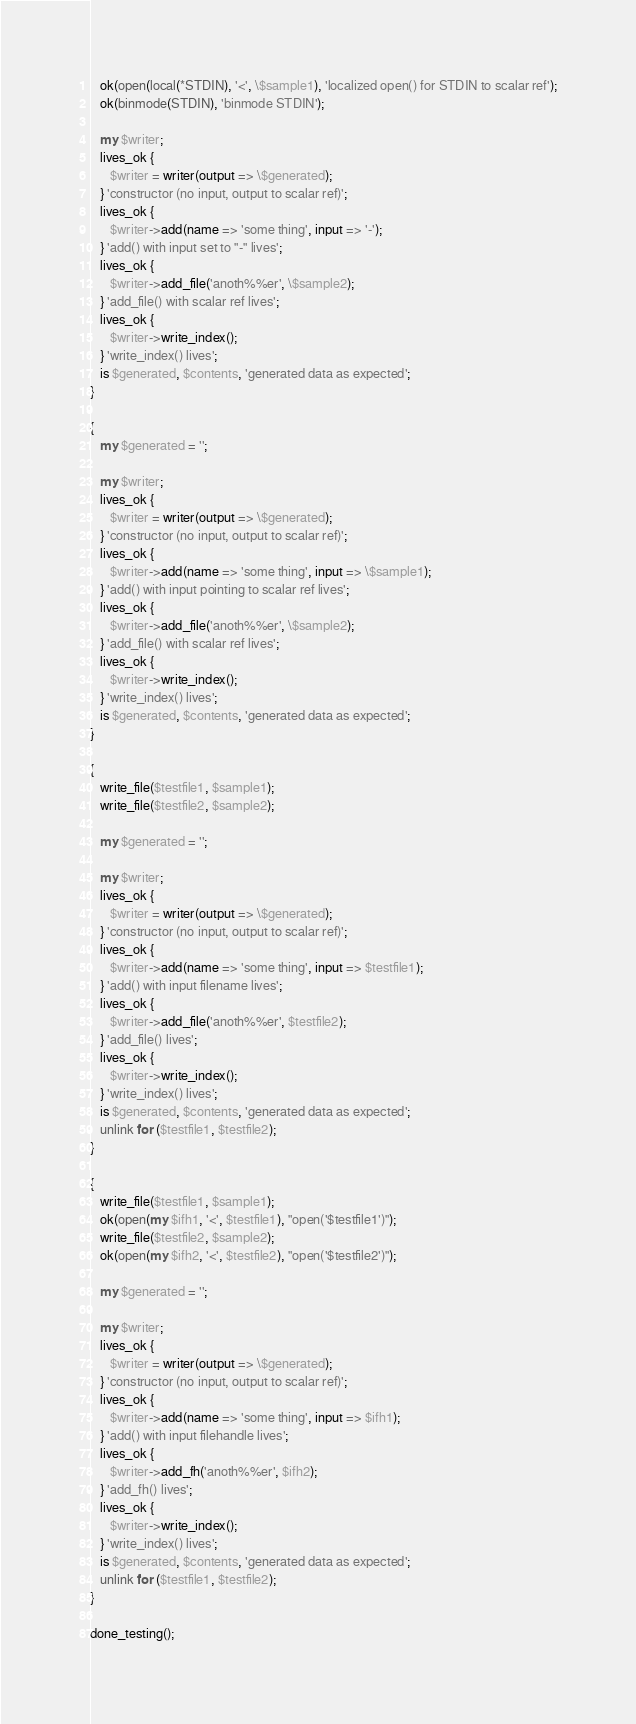Convert code to text. <code><loc_0><loc_0><loc_500><loc_500><_Perl_>   ok(open(local(*STDIN), '<', \$sample1), 'localized open() for STDIN to scalar ref');
   ok(binmode(STDIN), 'binmode STDIN');

   my $writer;
   lives_ok {
      $writer = writer(output => \$generated);
   } 'constructor (no input, output to scalar ref)';
   lives_ok {
      $writer->add(name => 'some thing', input => '-');
   } 'add() with input set to "-" lives';
   lives_ok {
      $writer->add_file('anoth%%er', \$sample2);
   } 'add_file() with scalar ref lives';
   lives_ok {
      $writer->write_index();
   } 'write_index() lives';
   is $generated, $contents, 'generated data as expected';
}

{
   my $generated = '';

   my $writer;
   lives_ok {
      $writer = writer(output => \$generated);
   } 'constructor (no input, output to scalar ref)';
   lives_ok {
      $writer->add(name => 'some thing', input => \$sample1);
   } 'add() with input pointing to scalar ref lives';
   lives_ok {
      $writer->add_file('anoth%%er', \$sample2);
   } 'add_file() with scalar ref lives';
   lives_ok {
      $writer->write_index();
   } 'write_index() lives';
   is $generated, $contents, 'generated data as expected';
}

{
   write_file($testfile1, $sample1);
   write_file($testfile2, $sample2);

   my $generated = '';

   my $writer;
   lives_ok {
      $writer = writer(output => \$generated);
   } 'constructor (no input, output to scalar ref)';
   lives_ok {
      $writer->add(name => 'some thing', input => $testfile1);
   } 'add() with input filename lives';
   lives_ok {
      $writer->add_file('anoth%%er', $testfile2);
   } 'add_file() lives';
   lives_ok {
      $writer->write_index();
   } 'write_index() lives';
   is $generated, $contents, 'generated data as expected';
   unlink for ($testfile1, $testfile2);
}

{
   write_file($testfile1, $sample1);
   ok(open(my $ifh1, '<', $testfile1), "open('$testfile1')");
   write_file($testfile2, $sample2);
   ok(open(my $ifh2, '<', $testfile2), "open('$testfile2')");

   my $generated = '';

   my $writer;
   lives_ok {
      $writer = writer(output => \$generated);
   } 'constructor (no input, output to scalar ref)';
   lives_ok {
      $writer->add(name => 'some thing', input => $ifh1);
   } 'add() with input filehandle lives';
   lives_ok {
      $writer->add_fh('anoth%%er', $ifh2);
   } 'add_fh() lives';
   lives_ok {
      $writer->write_index();
   } 'write_index() lives';
   is $generated, $contents, 'generated data as expected';
   unlink for ($testfile1, $testfile2);
}

done_testing();
</code> 